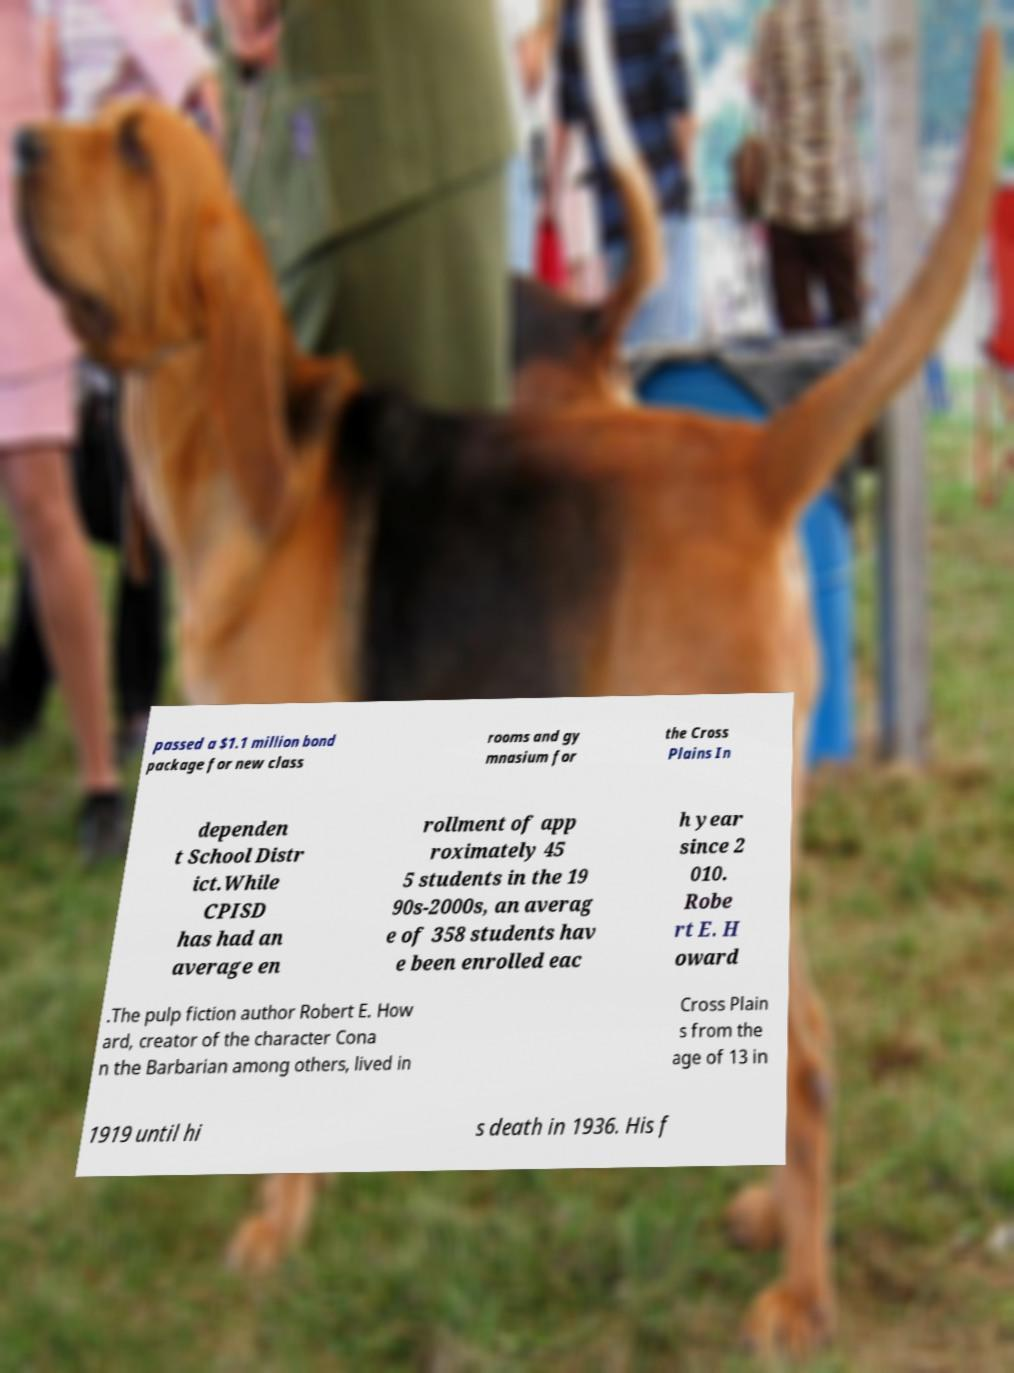Please identify and transcribe the text found in this image. passed a $1.1 million bond package for new class rooms and gy mnasium for the Cross Plains In dependen t School Distr ict.While CPISD has had an average en rollment of app roximately 45 5 students in the 19 90s-2000s, an averag e of 358 students hav e been enrolled eac h year since 2 010. Robe rt E. H oward .The pulp fiction author Robert E. How ard, creator of the character Cona n the Barbarian among others, lived in Cross Plain s from the age of 13 in 1919 until hi s death in 1936. His f 